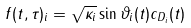Convert formula to latex. <formula><loc_0><loc_0><loc_500><loc_500>f ( t , \tau ) _ { i } = \sqrt { \kappa _ { i } } \sin \vartheta _ { i } ( t ) c _ { D _ { i } } ( t )</formula> 